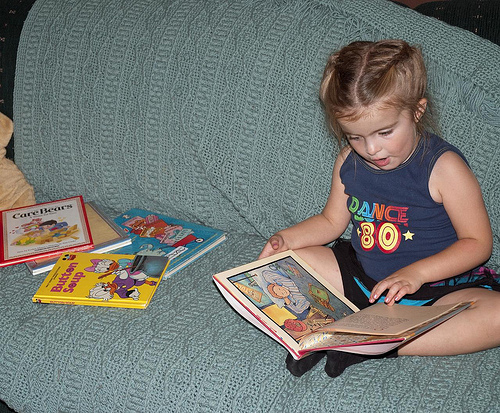<image>
Is there a book on the girl? Yes. Looking at the image, I can see the book is positioned on top of the girl, with the girl providing support. 